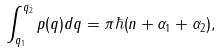Convert formula to latex. <formula><loc_0><loc_0><loc_500><loc_500>\int _ { q _ { 1 } } ^ { q _ { 2 } } p ( q ) d q = \pi \hbar { ( } n + \alpha _ { 1 } + \alpha _ { 2 } ) ,</formula> 